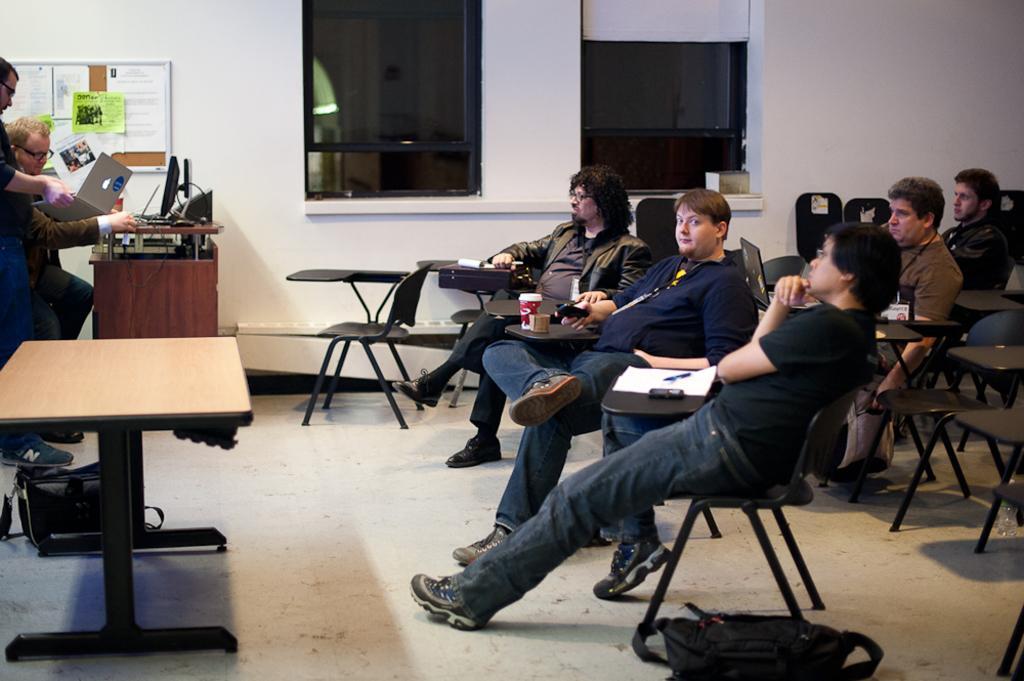Describe this image in one or two sentences. There are group of people sitting in chairs and there are two persons in front of them. 